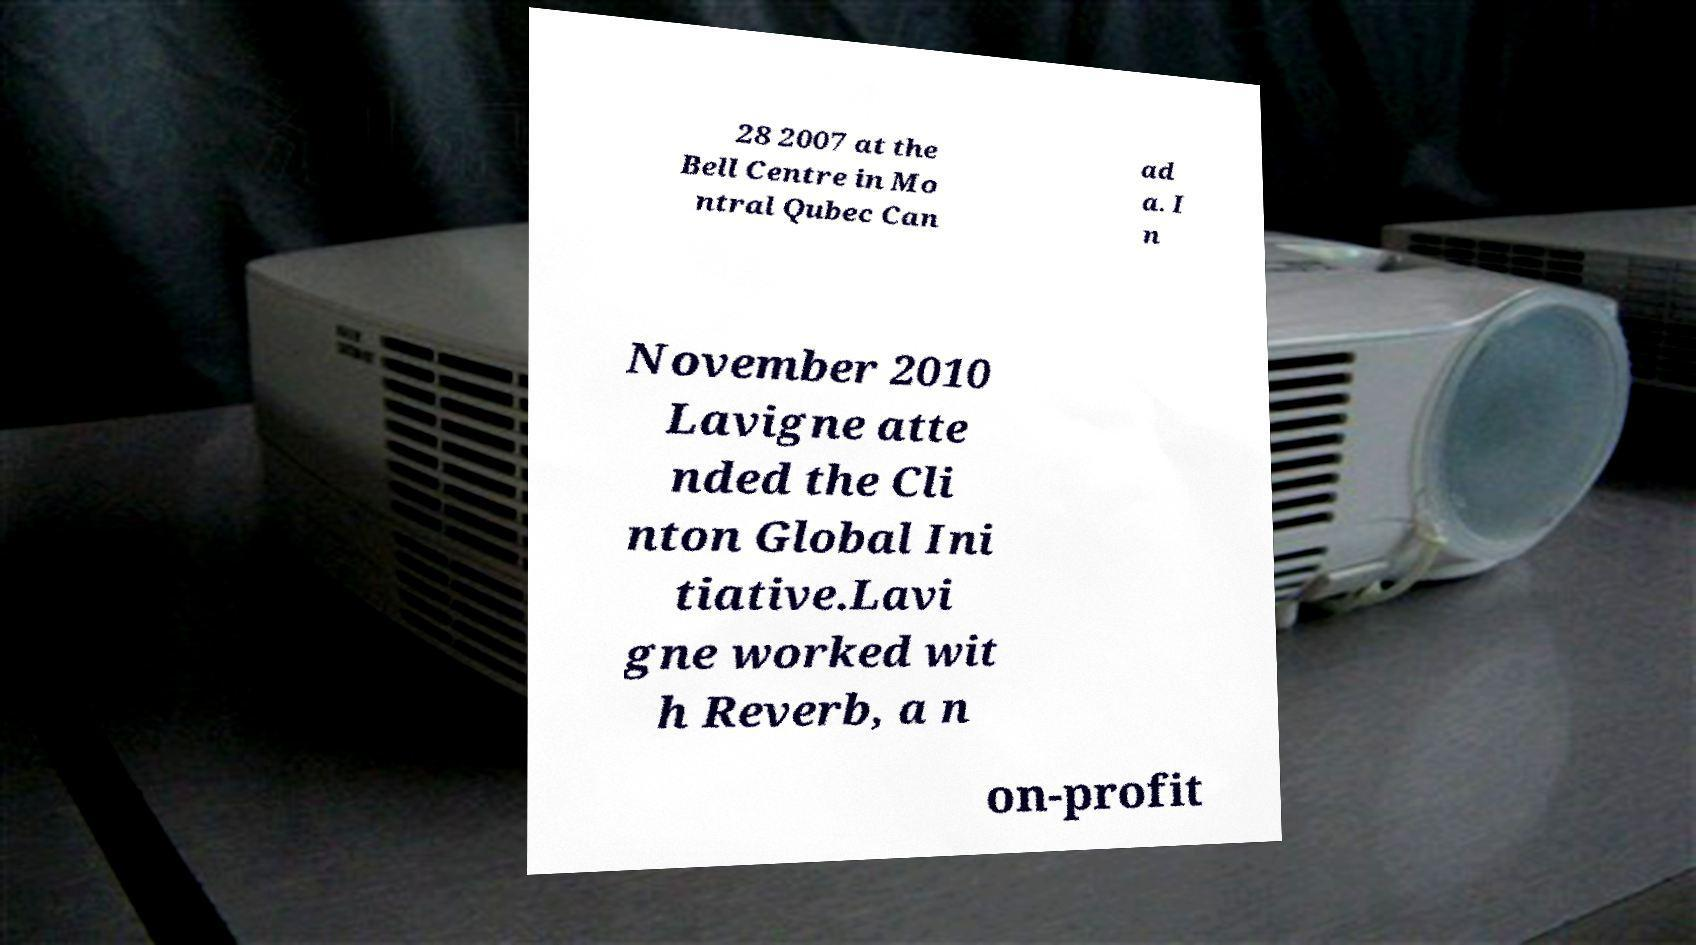What messages or text are displayed in this image? I need them in a readable, typed format. 28 2007 at the Bell Centre in Mo ntral Qubec Can ad a. I n November 2010 Lavigne atte nded the Cli nton Global Ini tiative.Lavi gne worked wit h Reverb, a n on-profit 